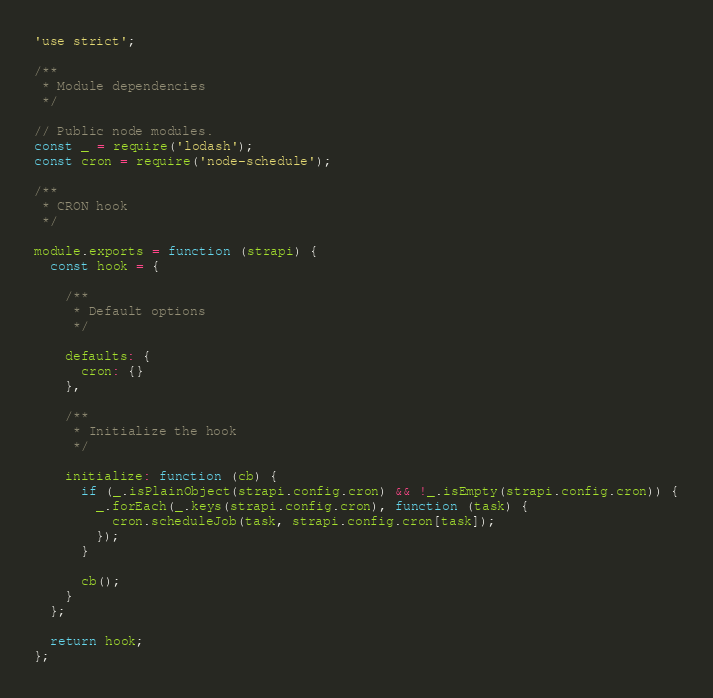Convert code to text. <code><loc_0><loc_0><loc_500><loc_500><_JavaScript_>'use strict';

/**
 * Module dependencies
 */

// Public node modules.
const _ = require('lodash');
const cron = require('node-schedule');

/**
 * CRON hook
 */

module.exports = function (strapi) {
  const hook = {

    /**
     * Default options
     */

    defaults: {
      cron: {}
    },

    /**
     * Initialize the hook
     */

    initialize: function (cb) {
      if (_.isPlainObject(strapi.config.cron) && !_.isEmpty(strapi.config.cron)) {
        _.forEach(_.keys(strapi.config.cron), function (task) {
          cron.scheduleJob(task, strapi.config.cron[task]);
        });
      }

      cb();
    }
  };

  return hook;
};
</code> 